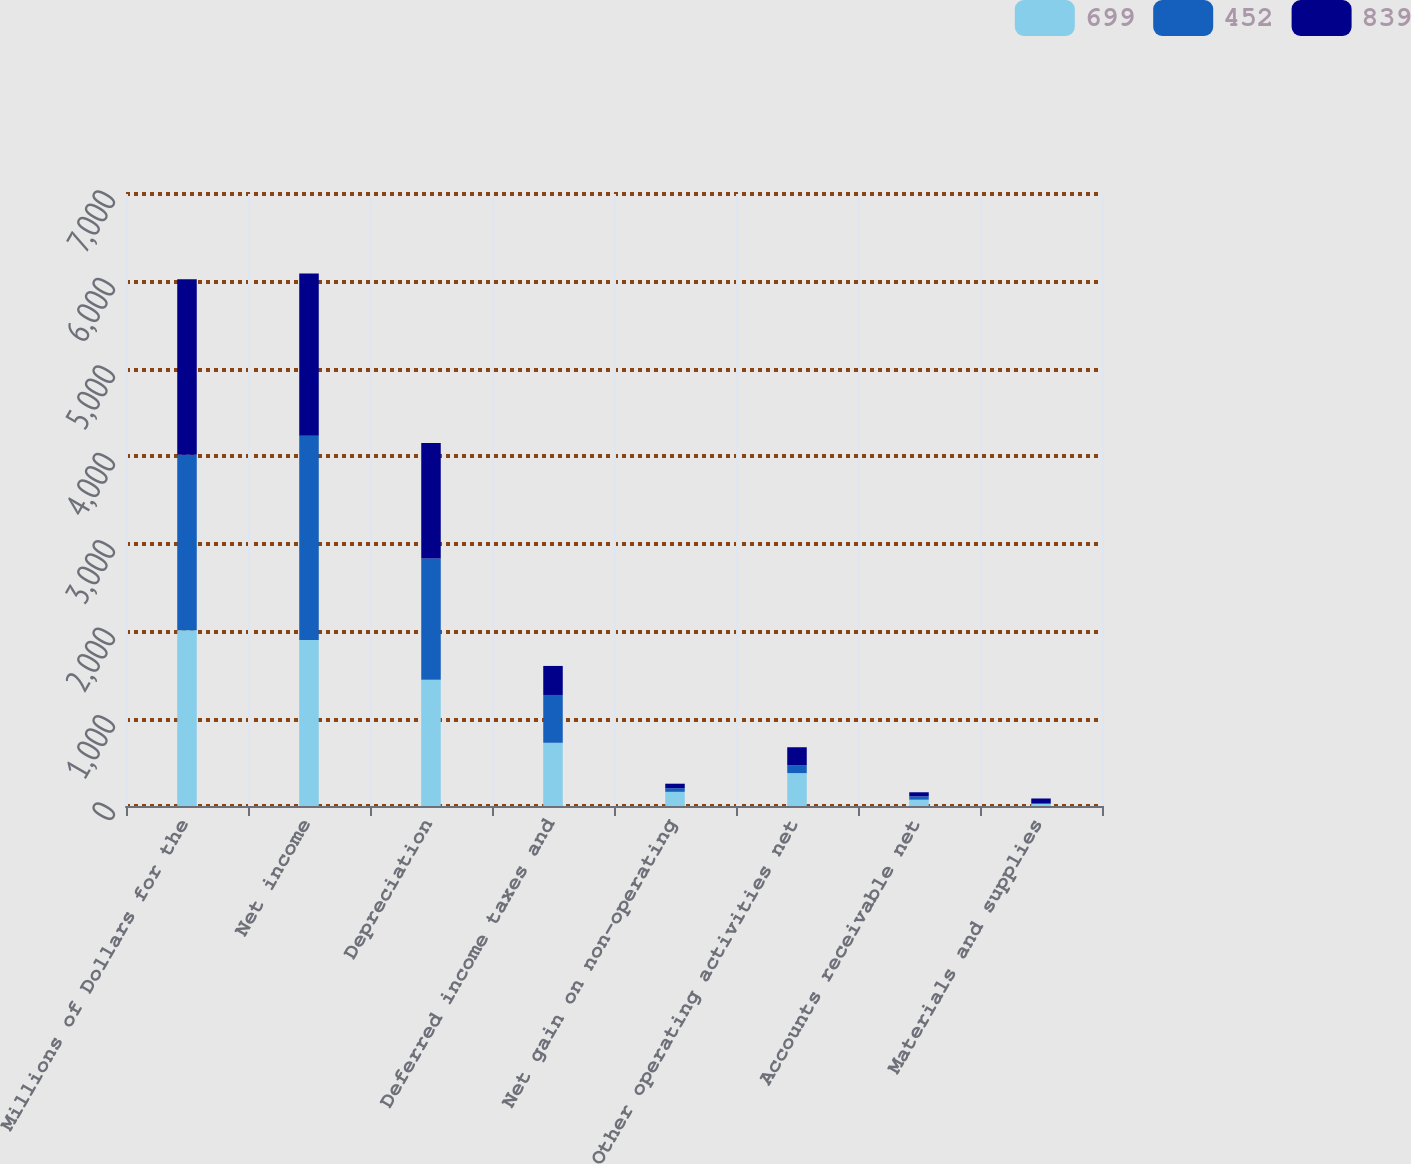Convert chart to OTSL. <chart><loc_0><loc_0><loc_500><loc_500><stacked_bar_chart><ecel><fcel>Millions of Dollars for the<fcel>Net income<fcel>Depreciation<fcel>Deferred income taxes and<fcel>Net gain on non-operating<fcel>Other operating activities net<fcel>Accounts receivable net<fcel>Materials and supplies<nl><fcel>699<fcel>2009<fcel>1898<fcel>1444<fcel>723<fcel>162<fcel>376<fcel>72<fcel>25<nl><fcel>452<fcel>2008<fcel>2338<fcel>1387<fcel>547<fcel>41<fcel>89<fcel>38<fcel>3<nl><fcel>839<fcel>2007<fcel>1855<fcel>1321<fcel>332<fcel>52<fcel>207<fcel>47<fcel>58<nl></chart> 